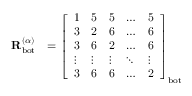Convert formula to latex. <formula><loc_0><loc_0><loc_500><loc_500>\begin{array} { r l } { R _ { b o t } ^ { ( \alpha ) } } & { = \left [ \begin{array} { l l l l l } { 1 } & { 5 } & { 5 } & { \dots } & { 5 } \\ { 3 } & { 2 } & { 6 } & { \dots } & { 6 } \\ { 3 } & { 6 } & { 2 } & { \dots } & { 6 } \\ { \vdots } & { \vdots } & { \vdots } & { \ddots } & { \vdots } \\ { 3 } & { 6 } & { 6 } & { \dots } & { 2 } \end{array} \right ] _ { b o t } } \end{array}</formula> 